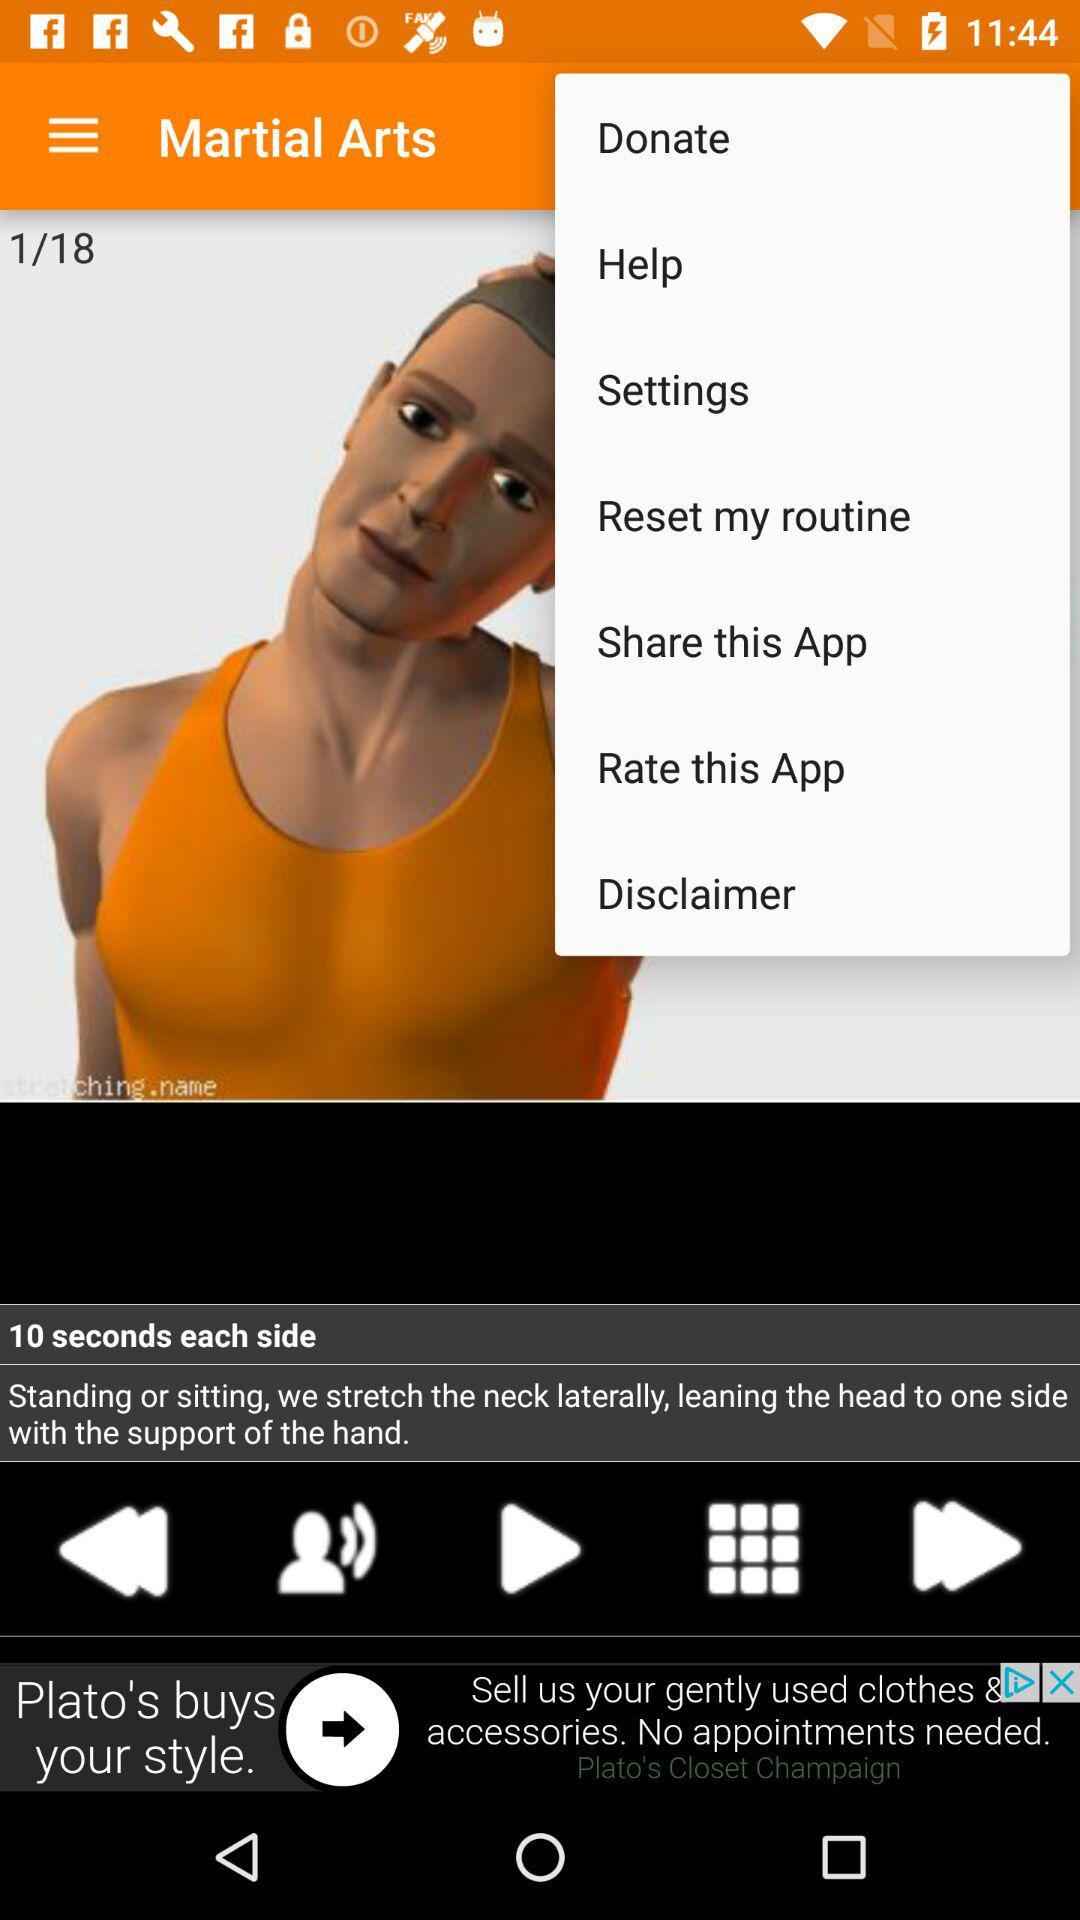What is the app name? The app name is "Martial Arts". 